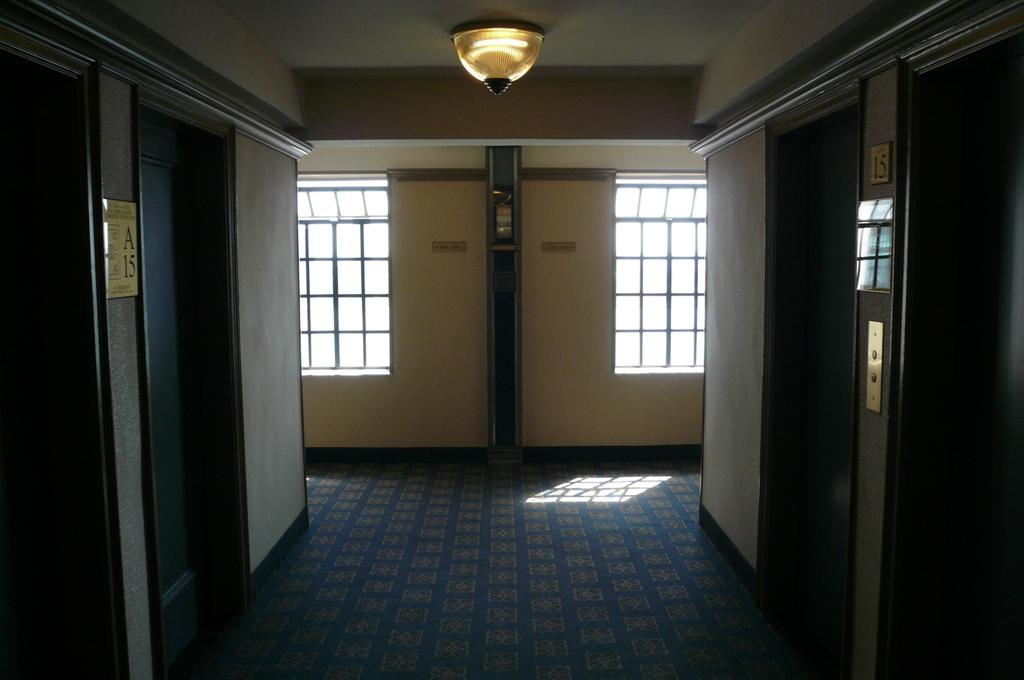What type of structure is visible in the image? There is a building in the image. How many doors can be seen on the building? There are doors on the left and right sides of the building. What architectural feature is present on the front of the building? There is a wall with windows in the front of the building. Can you describe the top of the building? There is light at the top of the building, possibly indicating a roof. What language is spoken by the people inside the building in the image? There is no indication of people or language spoken inside the building in the image. Can you tell me how many baths are visible in the image? There are no baths present in the image; it features a building with doors, windows, and a possible roof. 